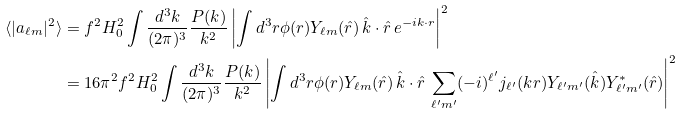<formula> <loc_0><loc_0><loc_500><loc_500>\langle | a _ { \ell m } | ^ { 2 } \rangle & = f ^ { 2 } H _ { 0 } ^ { 2 } \int \frac { d ^ { 3 } k } { ( 2 \pi ) ^ { 3 } } \frac { P ( k ) } { k ^ { 2 } } \left | \int d ^ { 3 } r \phi ( r ) Y _ { \ell m } ( \hat { r } ) \, \hat { k } \cdot \hat { r } \, e ^ { - i k \cdot r } \right | ^ { 2 } \\ & = 1 6 \pi ^ { 2 } f ^ { 2 } H _ { 0 } ^ { 2 } \int \frac { d ^ { 3 } k } { ( 2 \pi ) ^ { 3 } } \frac { P ( k ) } { k ^ { 2 } } \left | \int d ^ { 3 } r \phi ( r ) Y _ { \ell m } ( \hat { r } ) \, \hat { k } \cdot \hat { r } \, \sum _ { { \ell } ^ { \prime } m ^ { \prime } } ( - i ) ^ { { \ell } ^ { \prime } } j _ { { \ell } ^ { \prime } } ( k r ) Y _ { { \ell } ^ { \prime } m ^ { \prime } } ( \hat { k } ) Y _ { { \ell } ^ { \prime } m ^ { \prime } } ^ { \ast } ( \hat { r } ) \right | ^ { 2 }</formula> 